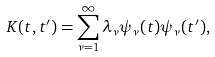<formula> <loc_0><loc_0><loc_500><loc_500>K ( t , t ^ { \prime } ) = \sum _ { \nu = 1 } ^ { \infty } \lambda _ { \nu } \psi _ { \nu } ( t ) \psi _ { \nu } ( t ^ { \prime } ) ,</formula> 